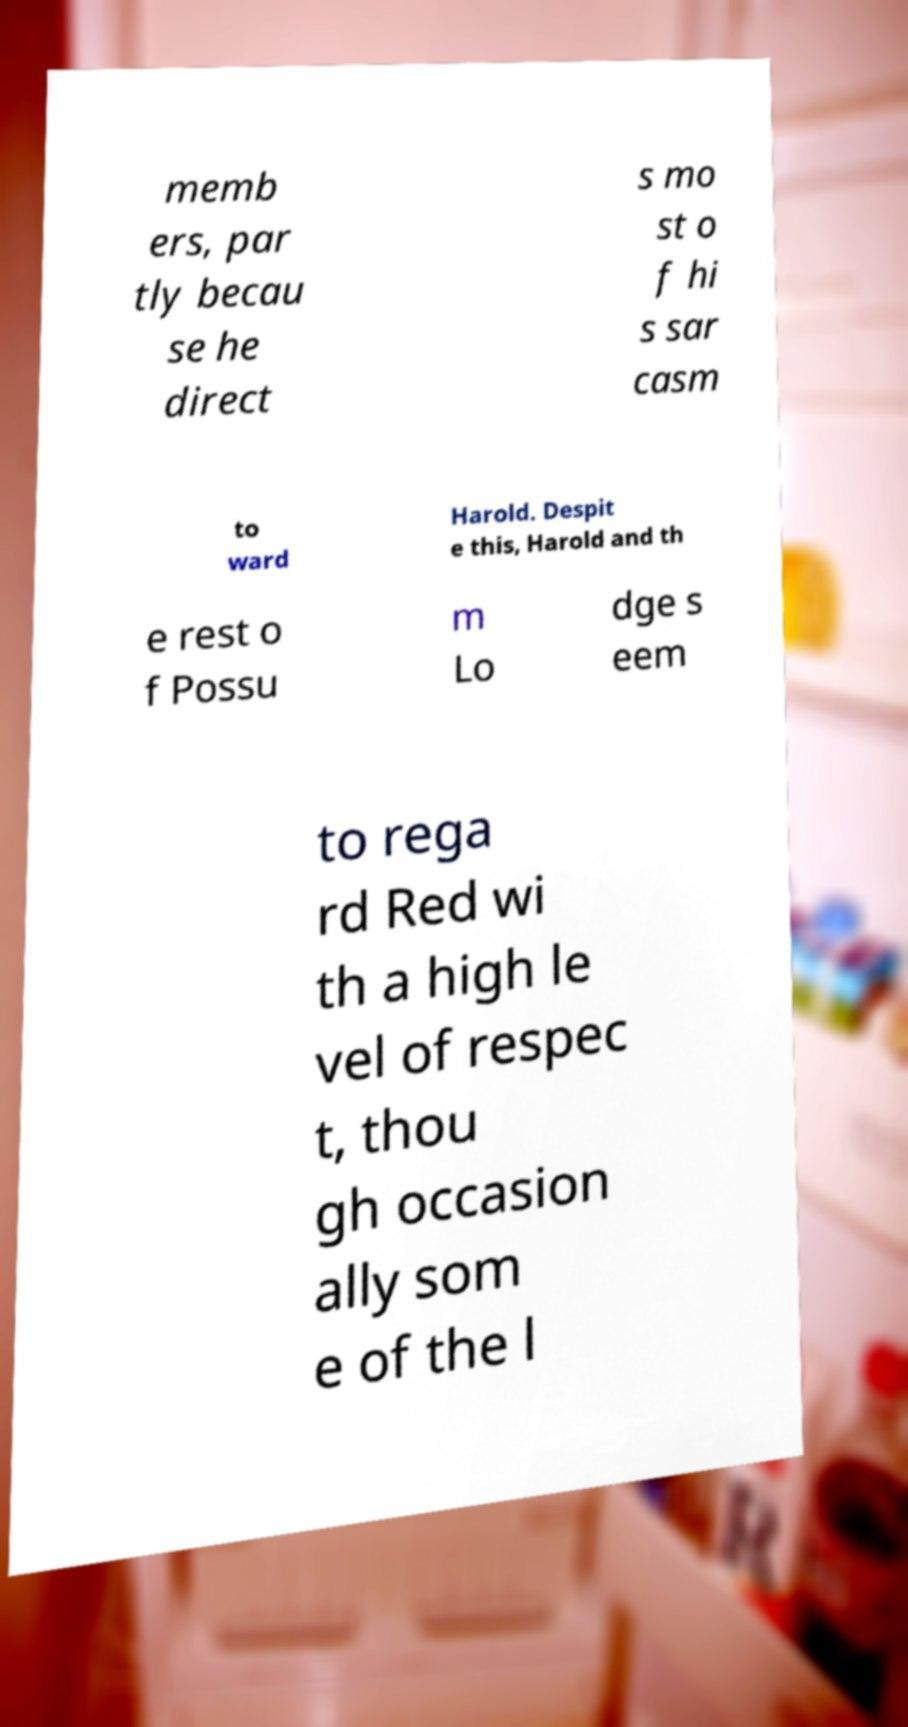There's text embedded in this image that I need extracted. Can you transcribe it verbatim? memb ers, par tly becau se he direct s mo st o f hi s sar casm to ward Harold. Despit e this, Harold and th e rest o f Possu m Lo dge s eem to rega rd Red wi th a high le vel of respec t, thou gh occasion ally som e of the l 